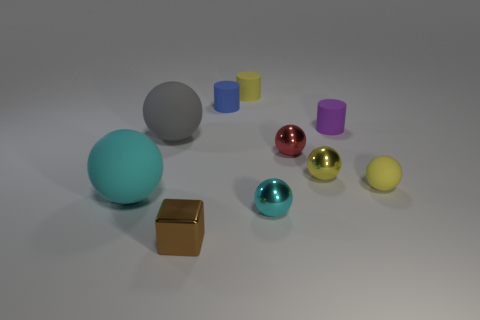There is another yellow thing that is the same shape as the yellow metal object; what material is it?
Give a very brief answer. Rubber. Is the number of big gray things that are behind the big gray thing the same as the number of green matte objects?
Provide a succinct answer. Yes. What size is the object that is both in front of the small yellow matte sphere and behind the cyan metal object?
Offer a terse response. Large. Is there any other thing that has the same color as the small cube?
Offer a very short reply. No. How big is the gray rubber object that is on the left side of the tiny yellow rubber thing in front of the gray matte thing?
Ensure brevity in your answer.  Large. The rubber sphere that is in front of the red ball and left of the yellow matte cylinder is what color?
Provide a succinct answer. Cyan. What number of other objects are the same size as the cyan rubber sphere?
Offer a terse response. 1. There is a brown metal object; is its size the same as the metallic sphere that is in front of the large cyan rubber thing?
Your response must be concise. Yes. The other matte sphere that is the same size as the cyan matte ball is what color?
Give a very brief answer. Gray. What is the size of the gray thing?
Your answer should be very brief. Large. 